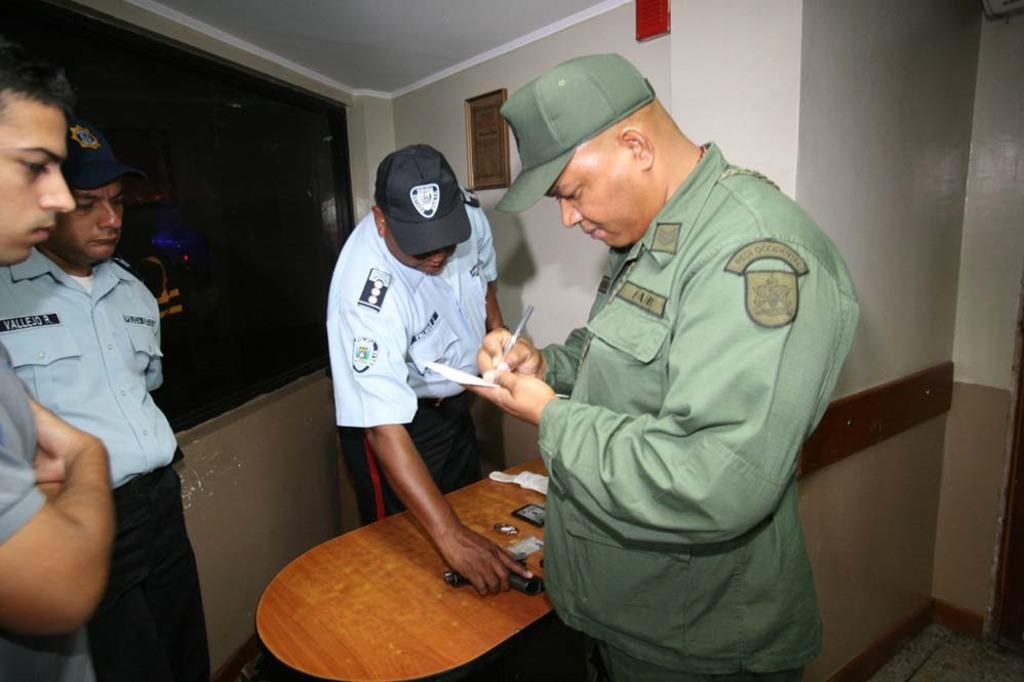How many people are in the image? There are four persons standing in the image. What is one person holding in the image? One person is holding a paper and pen. What can be seen in the background of the image? There is a wall and a screen in the background of the image. What piece of furniture is present in the image? There is a table in the image. What object is on the table? There is a gun on the table. What type of company is depicted on the screen in the image? There is no company depicted on the screen in the image; it is a background element and not the focus of the image. 